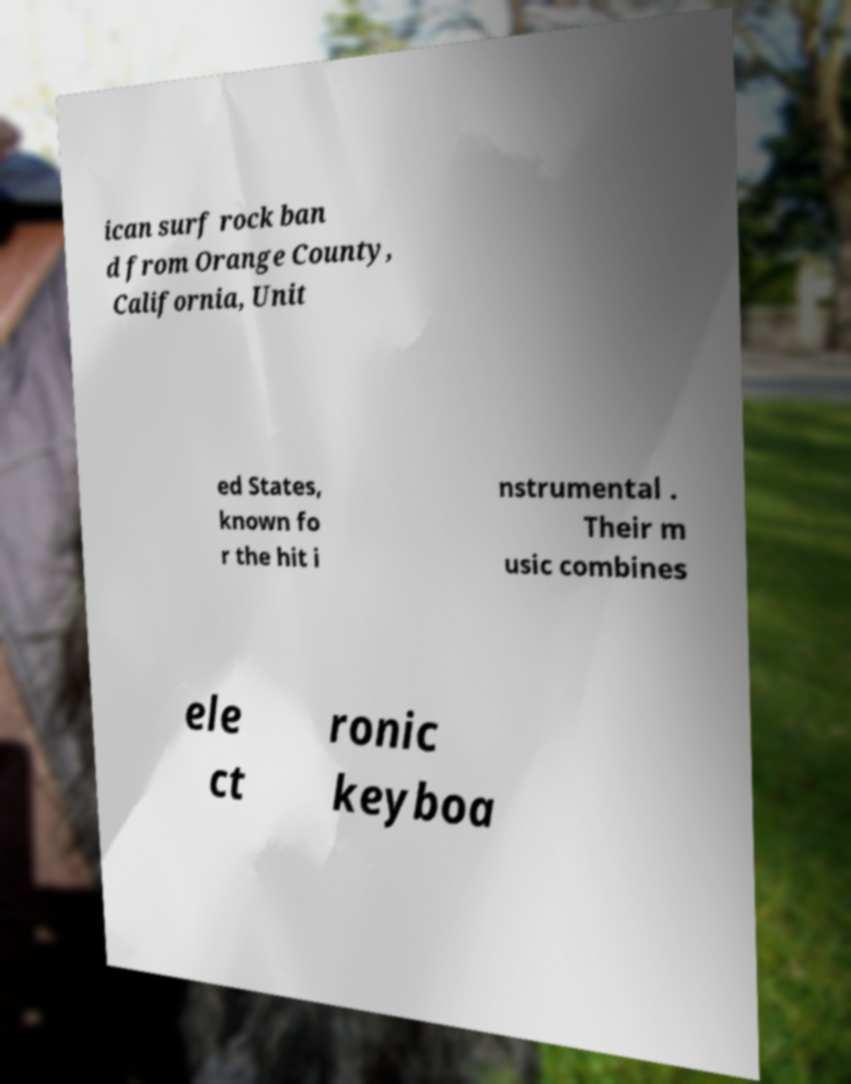Could you assist in decoding the text presented in this image and type it out clearly? ican surf rock ban d from Orange County, California, Unit ed States, known fo r the hit i nstrumental . Their m usic combines ele ct ronic keyboa 